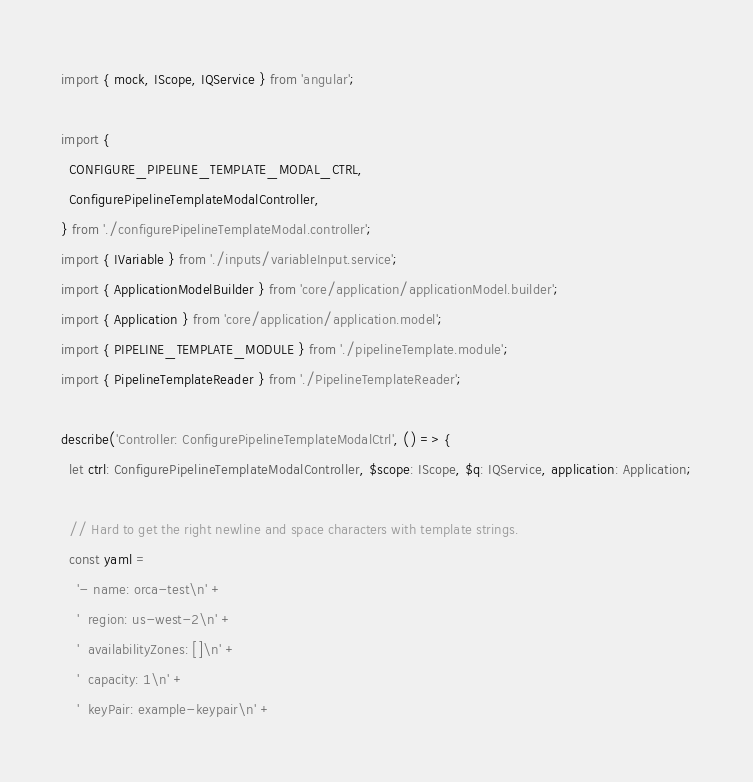Convert code to text. <code><loc_0><loc_0><loc_500><loc_500><_TypeScript_>import { mock, IScope, IQService } from 'angular';

import {
  CONFIGURE_PIPELINE_TEMPLATE_MODAL_CTRL,
  ConfigurePipelineTemplateModalController,
} from './configurePipelineTemplateModal.controller';
import { IVariable } from './inputs/variableInput.service';
import { ApplicationModelBuilder } from 'core/application/applicationModel.builder';
import { Application } from 'core/application/application.model';
import { PIPELINE_TEMPLATE_MODULE } from './pipelineTemplate.module';
import { PipelineTemplateReader } from './PipelineTemplateReader';

describe('Controller: ConfigurePipelineTemplateModalCtrl', () => {
  let ctrl: ConfigurePipelineTemplateModalController, $scope: IScope, $q: IQService, application: Application;

  // Hard to get the right newline and space characters with template strings.
  const yaml =
    '- name: orca-test\n' +
    '  region: us-west-2\n' +
    '  availabilityZones: []\n' +
    '  capacity: 1\n' +
    '  keyPair: example-keypair\n' +</code> 